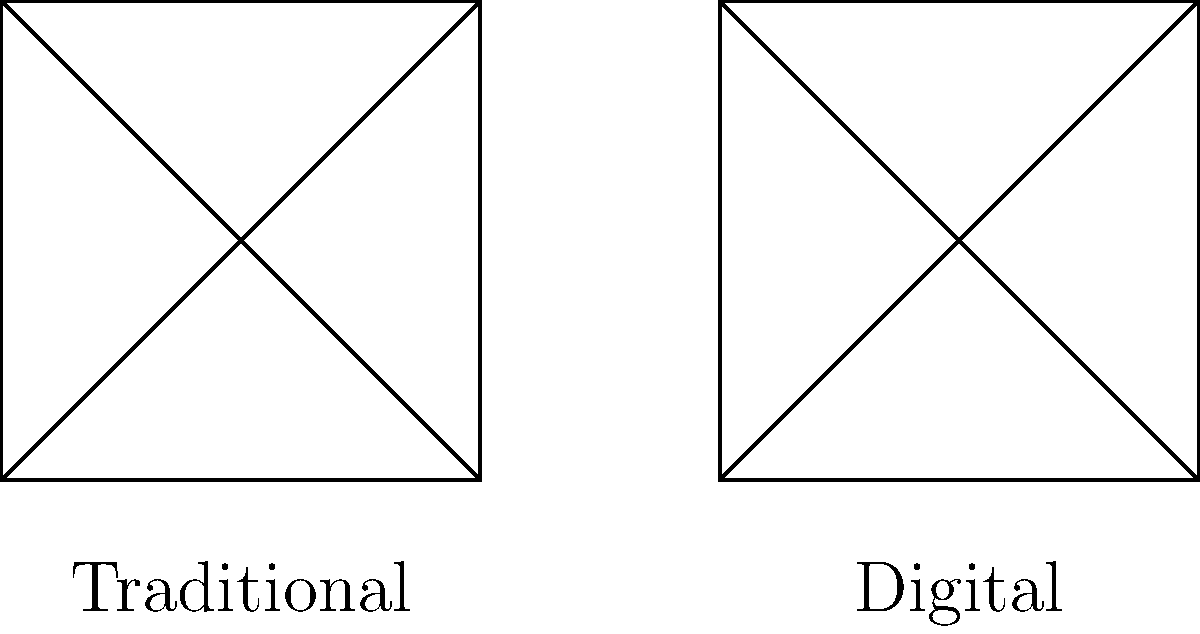In comparing the symmetry of traditional and digital comic book page layouts, which layout typically offers more flexibility for creating asymmetrical designs while maintaining visual balance? To answer this question, let's analyze the characteristics of both traditional and digital comic book page layouts:

1. Traditional layout:
   - Often based on a grid system
   - Typically uses rectangular panels
   - Symmetry is often achieved through balanced panel sizes and arrangements
   - Limited by physical page constraints

2. Digital layout:
   - Not restricted by physical page limitations
   - Can utilize non-rectangular shapes and dynamic panel arrangements
   - Allows for more experimental and asymmetrical designs
   - Can incorporate interactive elements and animations

3. Flexibility in asymmetry:
   - Digital layouts offer more freedom to create asymmetrical designs
   - Can easily adjust panel sizes, shapes, and positions without physical constraints
   - Allows for unique reading experiences through scrolling or tapping

4. Maintaining visual balance:
   - Digital tools provide precise control over element placement
   - Easy to experiment with different compositions
   - Can use layers and other digital techniques to create balance even in asymmetrical designs

5. Artistic perspective:
   - Digital artists can push boundaries of traditional comic book layouts
   - Asymmetrical designs can create dynamic visual interest and guide the reader's eye in new ways

Considering these factors, digital layouts offer more flexibility for creating asymmetrical designs while still maintaining visual balance due to the lack of physical constraints and the advanced tools available in digital platforms.
Answer: Digital layout 